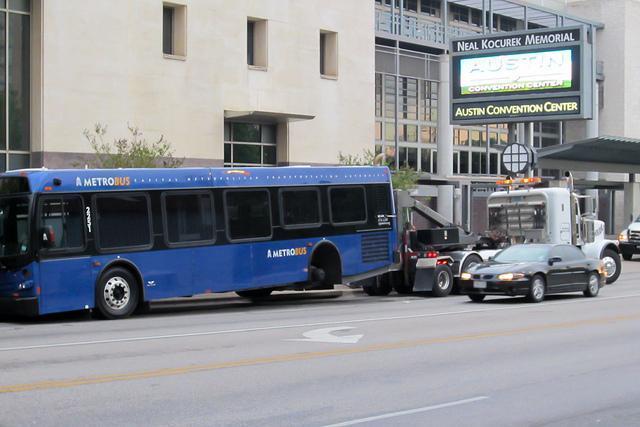How many tires are on the bus?
Give a very brief answer. 3. 